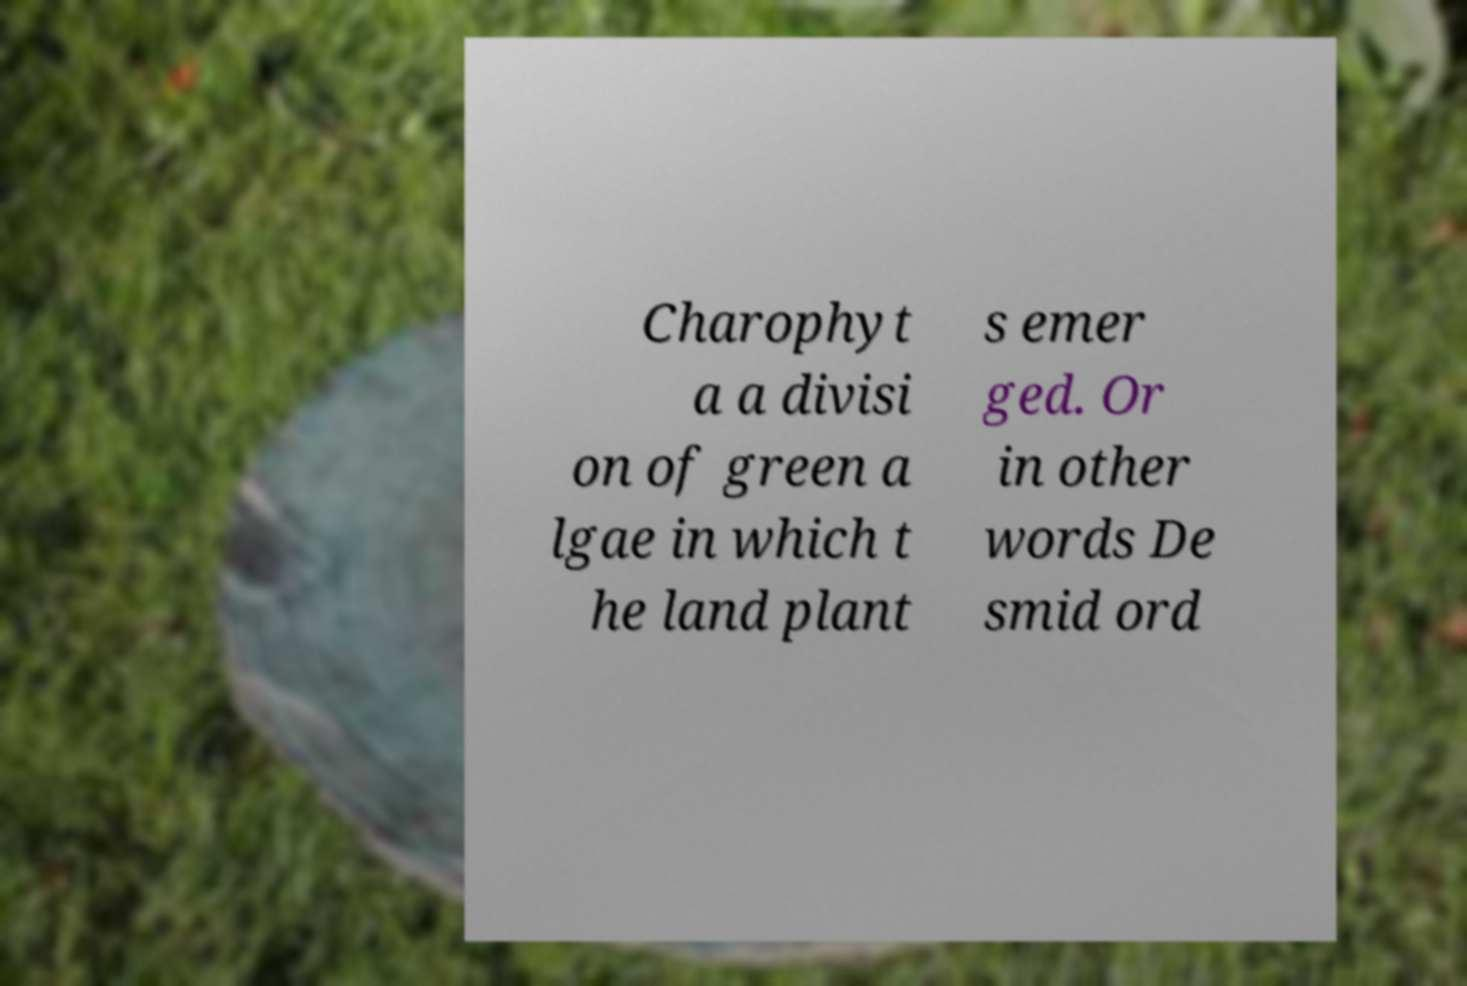What messages or text are displayed in this image? I need them in a readable, typed format. Charophyt a a divisi on of green a lgae in which t he land plant s emer ged. Or in other words De smid ord 